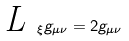<formula> <loc_0><loc_0><loc_500><loc_500>\emph { L } _ { \xi } g _ { \mu \nu } = 2 g _ { \mu \nu }</formula> 